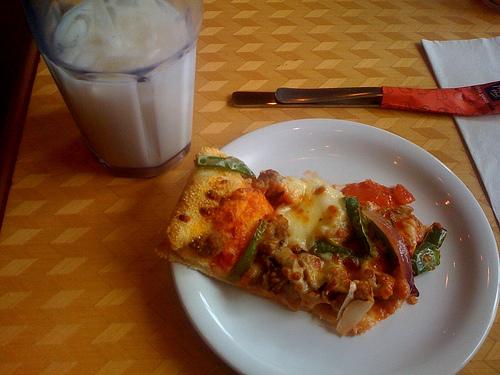What do you call this dish?
Write a very short answer. Pizza. Is there a beer on the table?
Short answer required. No. Is that a hot or cold beverage?
Write a very short answer. Cold. What shape is the plate?
Answer briefly. Circle. What type of wood table are the items sitting on?
Answer briefly. Bamboo. What is this a slice of?
Give a very brief answer. Pizza. What are the pizza toppings?
Quick response, please. Tomato and cheese. Has the knife been used recently?
Quick response, please. No. Is the glass half full?
Keep it brief. No. Where is this picture taken at?
Write a very short answer. Restaurant. Why would someone eat this?
Concise answer only. Hungry. Is this a pepperoni pizza slice?
Concise answer only. No. Is there a lace tablecloth?
Short answer required. No. What beverage is inside the cup?
Write a very short answer. Milk. What kind of food is shown?
Answer briefly. Pizza. Is this the main course?
Concise answer only. Yes. What vegetables are used?
Keep it brief. Peppers. What is he eating?
Write a very short answer. Pizza. What kind of meat is on the plate?
Give a very brief answer. Sausage. Would a vegan eat this?
Write a very short answer. No. What is the primary source of calcium in this meal?
Quick response, please. Cheese. Is the pizza round?
Quick response, please. No. Is the knife clean?
Write a very short answer. Yes. What is green color?
Quick response, please. Peppers. How many slices of pizza is there?
Concise answer only. 1. What is in the glass?
Be succinct. Milk. What is green on this pizza?
Be succinct. Peppers. What is the plate made of?
Write a very short answer. Ceramic. What color is the plate?
Short answer required. White. Is there a pizza cutter in the photo?
Answer briefly. No. What are the colors of the plate?
Answer briefly. White. What meal is this for?
Quick response, please. Lunch. Do you see any eating utensils?
Give a very brief answer. Yes. What type of food is on the white plate?
Be succinct. Pizza. Is this a healthy meal?
Keep it brief. No. How many slices are on the plate?
Answer briefly. 1. What color is the napkin?
Concise answer only. White. Are the plates made of glass?
Short answer required. Yes. What kind of food is on the plate?
Keep it brief. Pizza. Is there salt on the table?
Keep it brief. No. Where is the napkin?
Answer briefly. Right. Is there tea in the glass?
Short answer required. No. Is this on a plate or in a bowl?
Answer briefly. Plate. What meal of the day is this?
Be succinct. Lunch. What's in the glass?
Quick response, please. Milk. What is the food served on?
Concise answer only. Plate. Is this a healthy dinner?
Answer briefly. No. What is on top of this piece of pizza?
Concise answer only. Peppers. Is this a home cooked meal?
Concise answer only. No. What shape is this pizza slice?
Give a very brief answer. Rectangle. Is this pizza symmetrical?
Quick response, please. No. Is there a Coke on the table?
Be succinct. No. What is in the plate?
Write a very short answer. Pizza. How many pieces are there?
Keep it brief. 1. Would the food in the bowl burn your mouth when eaten as served?
Give a very brief answer. Yes. How many tomato slices are on the salad?
Give a very brief answer. 0. What cooking utensil can be seen on the table?
Keep it brief. Fork. What is on the plate?
Concise answer only. Pizza. What type of food is this?
Write a very short answer. Pizza. Is this a grilled cheese?
Answer briefly. No. Is there hot sauce on the table?
Keep it brief. No. What beverage is in the mug?
Answer briefly. Milk. What beverage is in the glass?
Be succinct. Milk. What type of drink is in the glass?
Keep it brief. Milk. What is in the cup?
Be succinct. Milk. What kind of counter is the food sitting on?
Quick response, please. Table. What is in the jar to the left of the plate?
Write a very short answer. Milk. What is this type of food called?
Short answer required. Pizza. What color is the tablecloth?
Answer briefly. Orange. What shape is the pizza slice?
Be succinct. Rectangle. Is this portion large?
Be succinct. No. What part of the fork can you see?
Give a very brief answer. Handle. Are there any utensils?
Concise answer only. Yes. What is the utensil on the right side of the plate?
Concise answer only. Fork. Are they having macaroni and cheese?
Keep it brief. No. What beverage is on the table?
Answer briefly. Milk. How many different foods are on the plate?
Quick response, please. 1. IS there a salad on the plate?
Write a very short answer. No. 